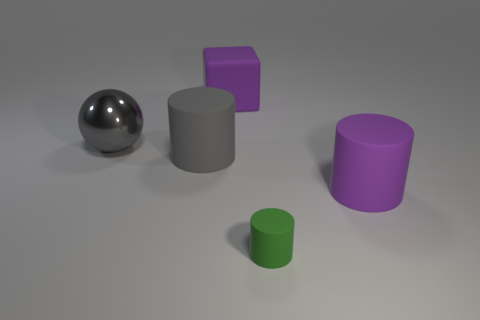What shapes are present in the image, and how many of each can you see? In the image, there are three unique shapes: one sphere, two cylinders, and one cube. The sphere and cube are each present as a single item, whereas the cylinders appear twice, differing in size and possibly in material finish. What can you infer about the textures of these objects? The objects in the image appear to have different textures. The sphere has a reflective and likely smooth texture. The cylinders and cube seem to have a matte finish, indicating a non-reflective, likely textured surface. 